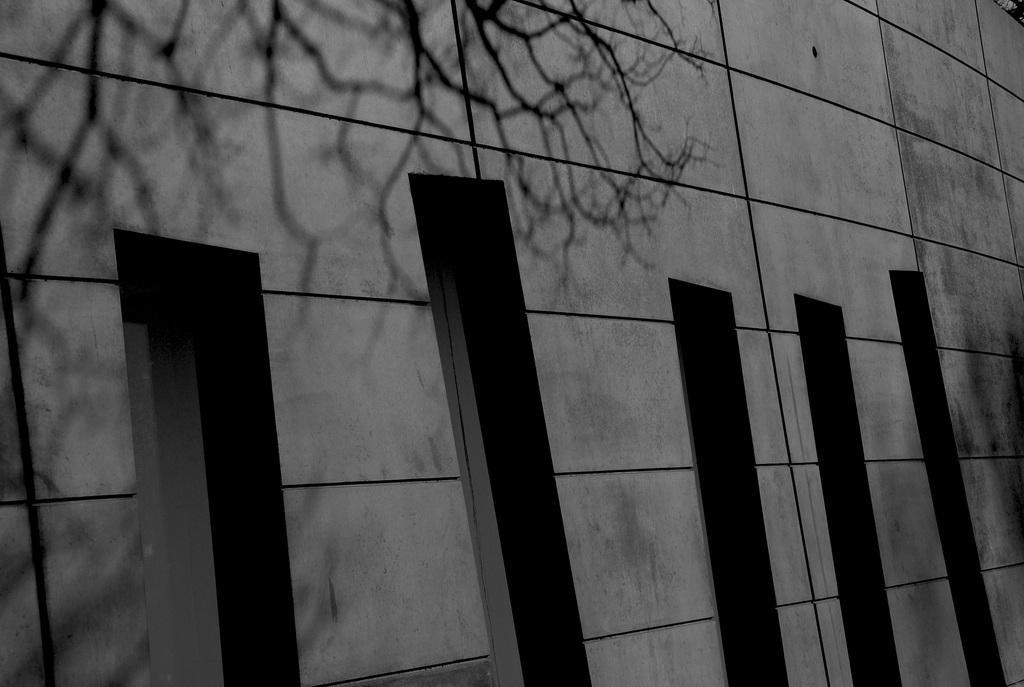In one or two sentences, can you explain what this image depicts? In this image, we can see a wall. 